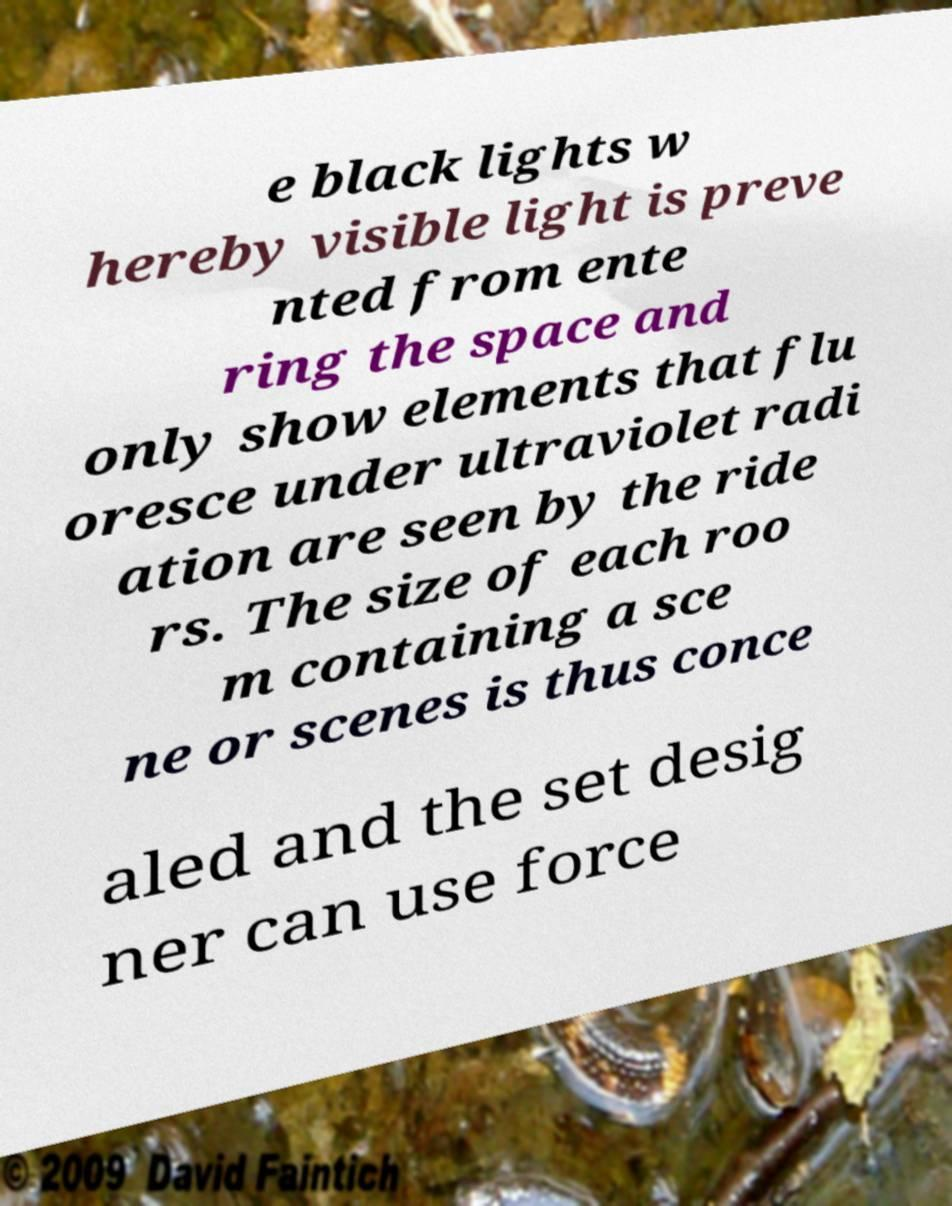Can you read and provide the text displayed in the image?This photo seems to have some interesting text. Can you extract and type it out for me? e black lights w hereby visible light is preve nted from ente ring the space and only show elements that flu oresce under ultraviolet radi ation are seen by the ride rs. The size of each roo m containing a sce ne or scenes is thus conce aled and the set desig ner can use force 